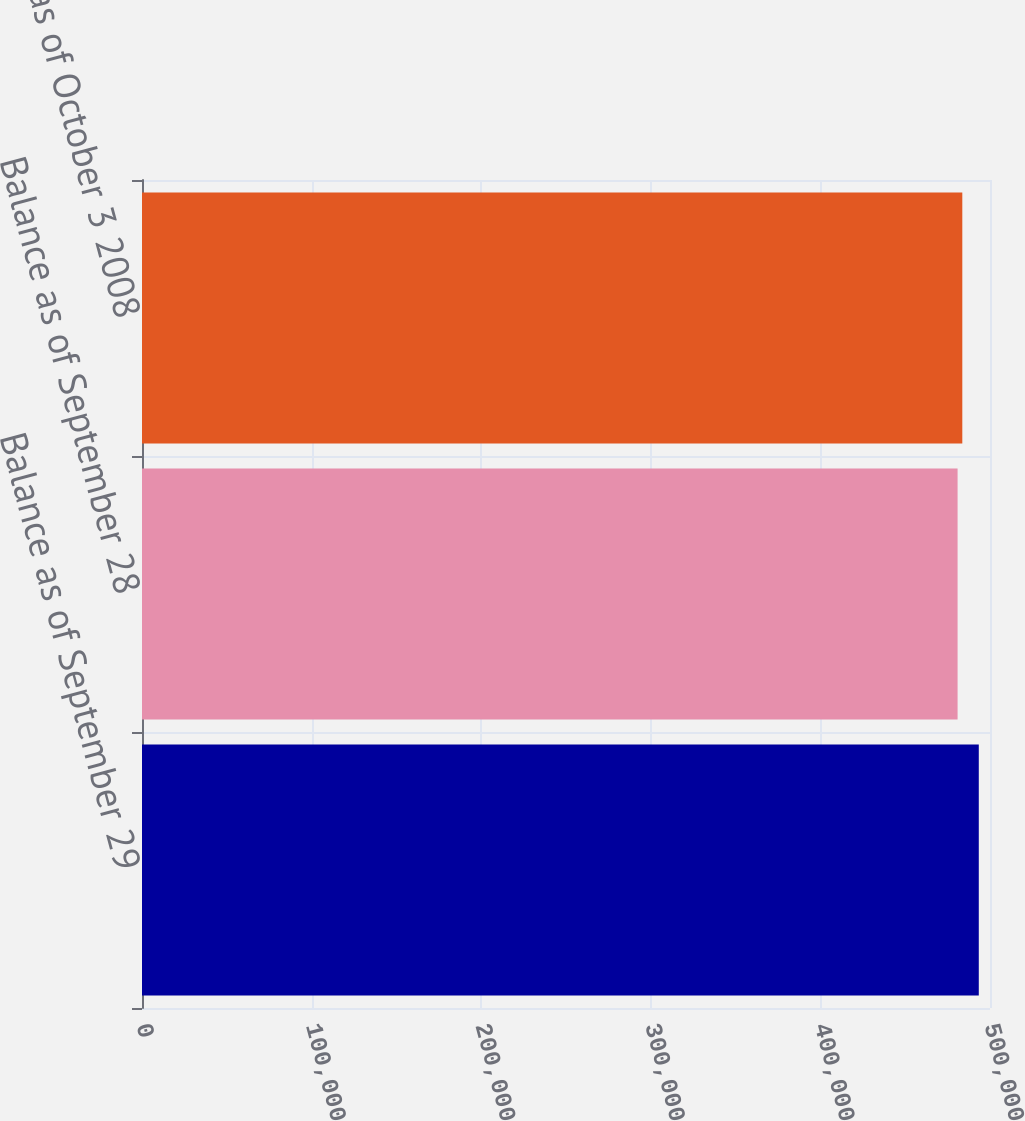Convert chart. <chart><loc_0><loc_0><loc_500><loc_500><bar_chart><fcel>Balance as of September 29<fcel>Balance as of September 28<fcel>Balance as of October 3 2008<nl><fcel>493389<fcel>480890<fcel>483671<nl></chart> 